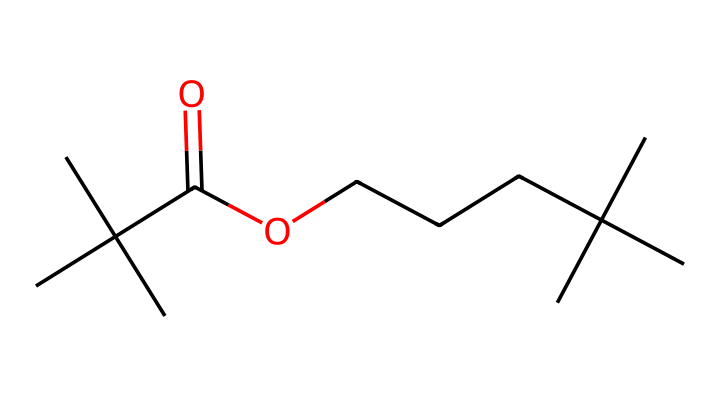What is the total number of carbon atoms in this chemical? By analyzing the SMILES representation, we can count the number of carbon (C) atoms present: there are 14 carbon atoms in total.
Answer: 14 What functional groups are present in this chemical? The chemical features a carboxylic acid group (–COOH), which is indicated by the -C(=O)O part of the SMILES representation. This is characteristic of acids due to the presence of a carbonyl (C=O) and a hydroxyl (–OH) group.
Answer: carboxylic acid How many hydrogen atoms are there in this compound? To determine the number of hydrogen (H) atoms, we consider the valency of carbon and account for the bonds present. Given the structure with 14 carbons and 2 oxygens, there are 28 hydrogen atoms.
Answer: 28 What type of plastic is suggested by its structure? The presence of branching and a carboxylic acid group suggests a type of polyolefin, possibly associated with thermoplastic elastomers due to its flexible structure, often related to durable plastics.
Answer: polyolefin Does this molecule show signs of plasticity? Yes, the branched carbon structure of this chemical allows for flexibility and resilience, indicating that it exhibits characteristics typical of plastic materials.
Answer: yes What is the significance of the branching in this plastic? The branching in the carbon chain enhances the mechanical properties of the plastic, contributing to its durability and resistance to deformation under stress, which is crucial for bookshelf designs in a futuristic setting.
Answer: mechanical properties 